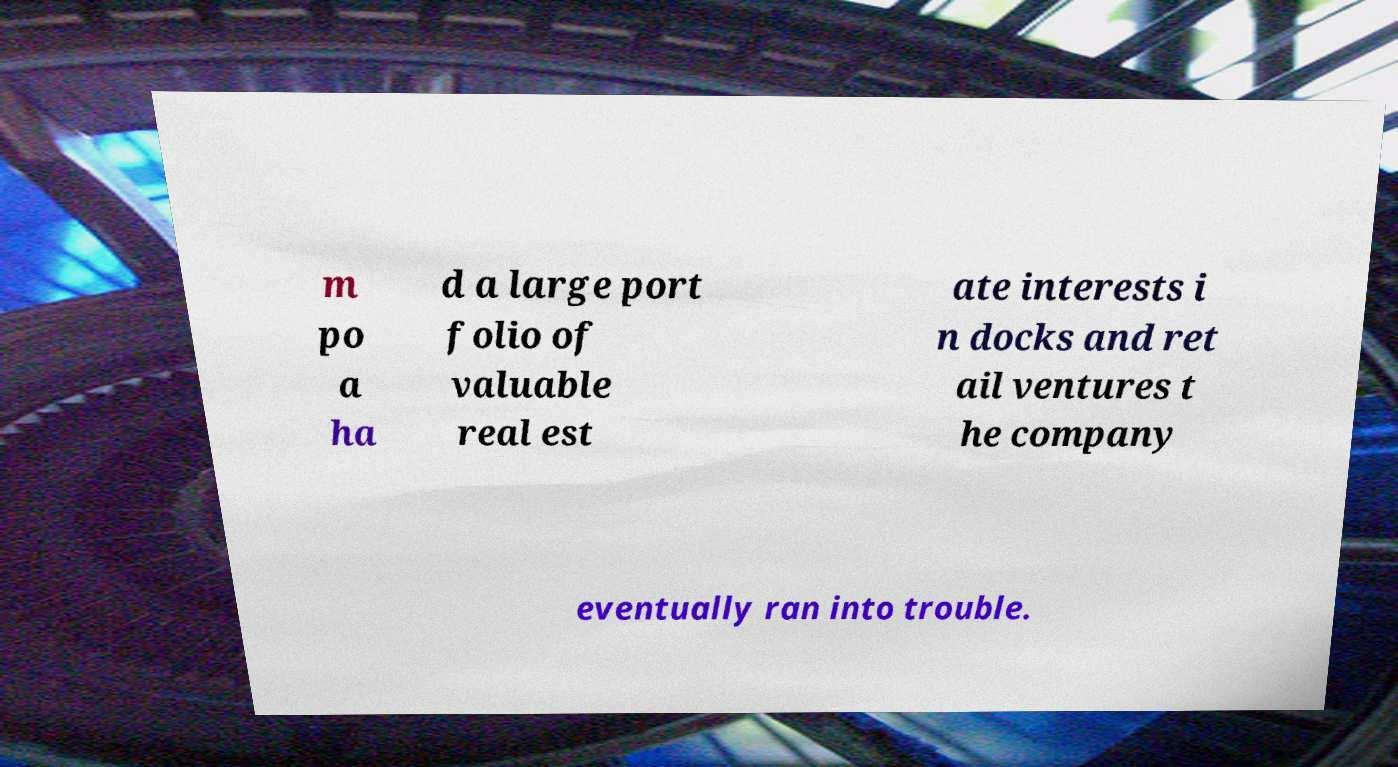What messages or text are displayed in this image? I need them in a readable, typed format. m po a ha d a large port folio of valuable real est ate interests i n docks and ret ail ventures t he company eventually ran into trouble. 